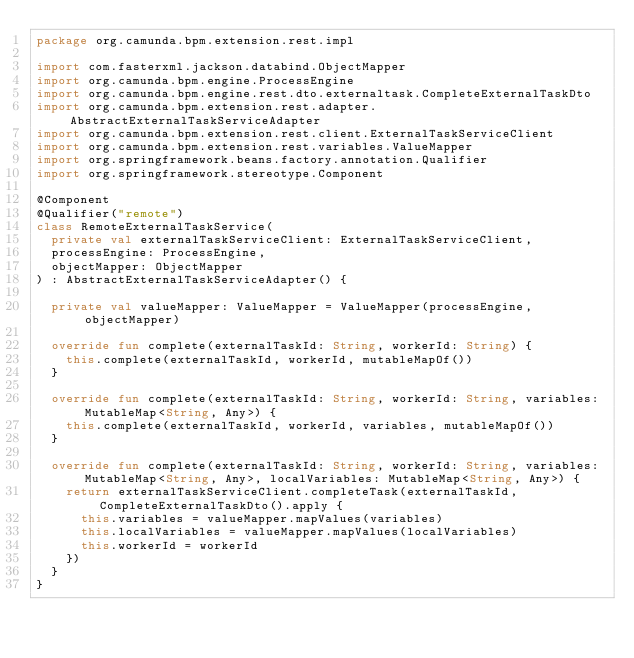Convert code to text. <code><loc_0><loc_0><loc_500><loc_500><_Kotlin_>package org.camunda.bpm.extension.rest.impl

import com.fasterxml.jackson.databind.ObjectMapper
import org.camunda.bpm.engine.ProcessEngine
import org.camunda.bpm.engine.rest.dto.externaltask.CompleteExternalTaskDto
import org.camunda.bpm.extension.rest.adapter.AbstractExternalTaskServiceAdapter
import org.camunda.bpm.extension.rest.client.ExternalTaskServiceClient
import org.camunda.bpm.extension.rest.variables.ValueMapper
import org.springframework.beans.factory.annotation.Qualifier
import org.springframework.stereotype.Component

@Component
@Qualifier("remote")
class RemoteExternalTaskService(
  private val externalTaskServiceClient: ExternalTaskServiceClient,
  processEngine: ProcessEngine,
  objectMapper: ObjectMapper
) : AbstractExternalTaskServiceAdapter() {

  private val valueMapper: ValueMapper = ValueMapper(processEngine, objectMapper)

  override fun complete(externalTaskId: String, workerId: String) {
    this.complete(externalTaskId, workerId, mutableMapOf())
  }

  override fun complete(externalTaskId: String, workerId: String, variables: MutableMap<String, Any>) {
    this.complete(externalTaskId, workerId, variables, mutableMapOf())
  }

  override fun complete(externalTaskId: String, workerId: String, variables: MutableMap<String, Any>, localVariables: MutableMap<String, Any>) {
    return externalTaskServiceClient.completeTask(externalTaskId, CompleteExternalTaskDto().apply {
      this.variables = valueMapper.mapValues(variables)
      this.localVariables = valueMapper.mapValues(localVariables)
      this.workerId = workerId
    })
  }
}
</code> 